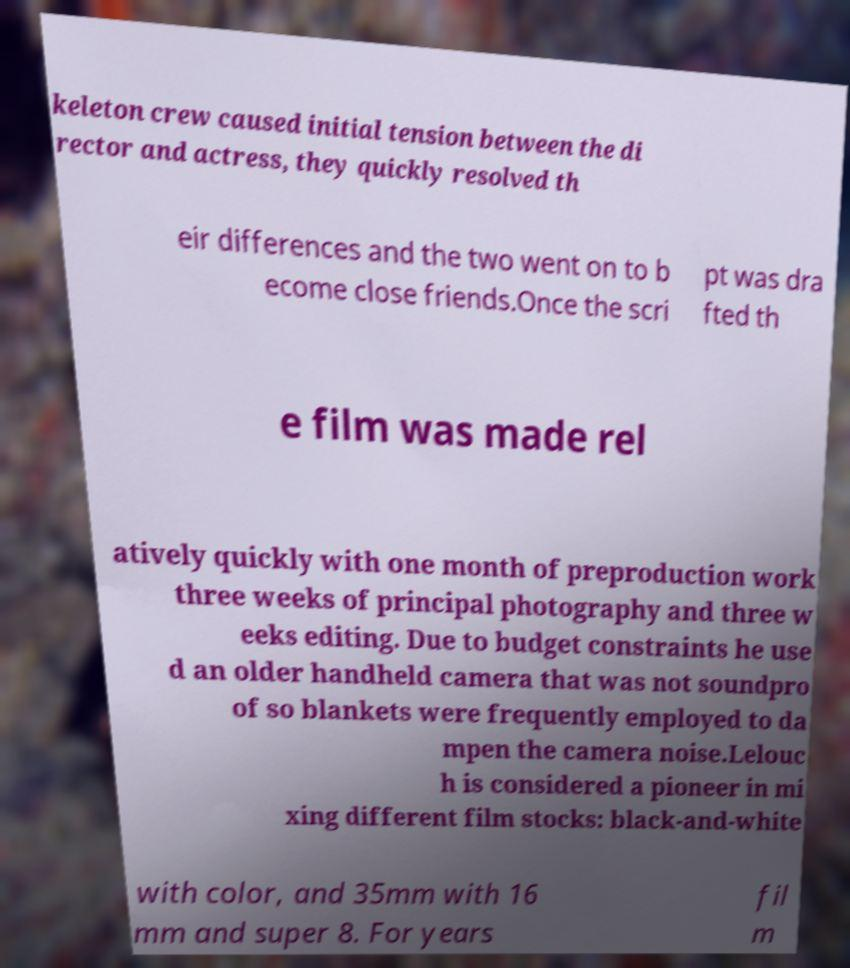Please read and relay the text visible in this image. What does it say? keleton crew caused initial tension between the di rector and actress, they quickly resolved th eir differences and the two went on to b ecome close friends.Once the scri pt was dra fted th e film was made rel atively quickly with one month of preproduction work three weeks of principal photography and three w eeks editing. Due to budget constraints he use d an older handheld camera that was not soundpro of so blankets were frequently employed to da mpen the camera noise.Lelouc h is considered a pioneer in mi xing different film stocks: black-and-white with color, and 35mm with 16 mm and super 8. For years fil m 